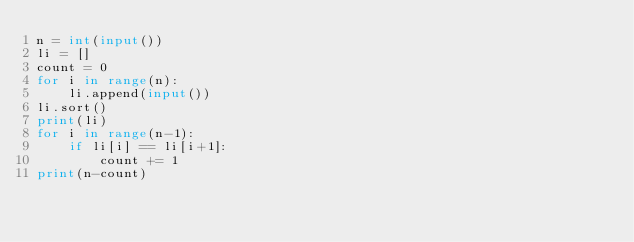<code> <loc_0><loc_0><loc_500><loc_500><_Python_>n = int(input())
li = []
count = 0
for i in range(n):
    li.append(input())
li.sort()
print(li)
for i in range(n-1):
    if li[i] == li[i+1]:
        count += 1
print(n-count)</code> 